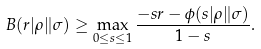<formula> <loc_0><loc_0><loc_500><loc_500>B ( r | \rho \| \sigma ) \geq \max _ { 0 \leq s \leq 1 } \frac { - s r - \phi ( s | \rho \| \sigma ) } { 1 - s } .</formula> 